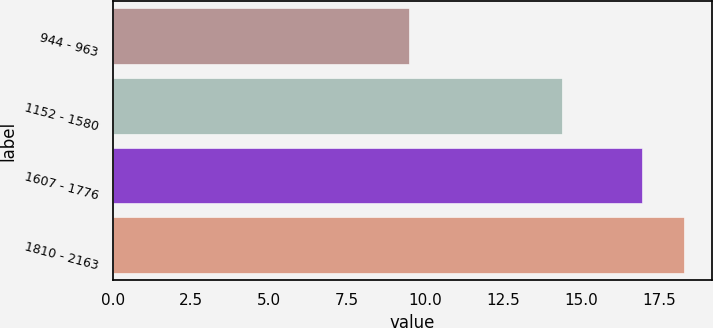Convert chart. <chart><loc_0><loc_0><loc_500><loc_500><bar_chart><fcel>944 - 963<fcel>1152 - 1580<fcel>1607 - 1776<fcel>1810 - 2163<nl><fcel>9.47<fcel>14.39<fcel>16.95<fcel>18.28<nl></chart> 